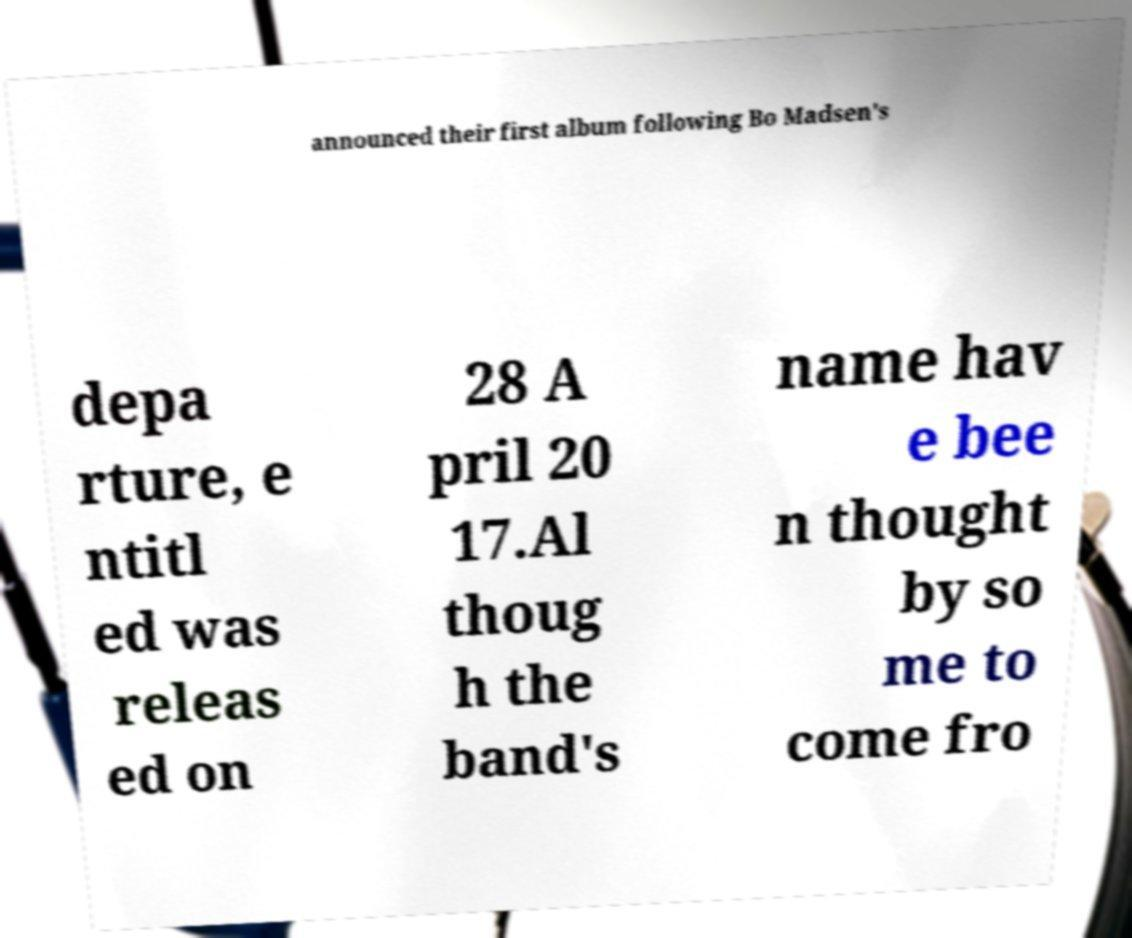For documentation purposes, I need the text within this image transcribed. Could you provide that? announced their first album following Bo Madsen's depa rture, e ntitl ed was releas ed on 28 A pril 20 17.Al thoug h the band's name hav e bee n thought by so me to come fro 